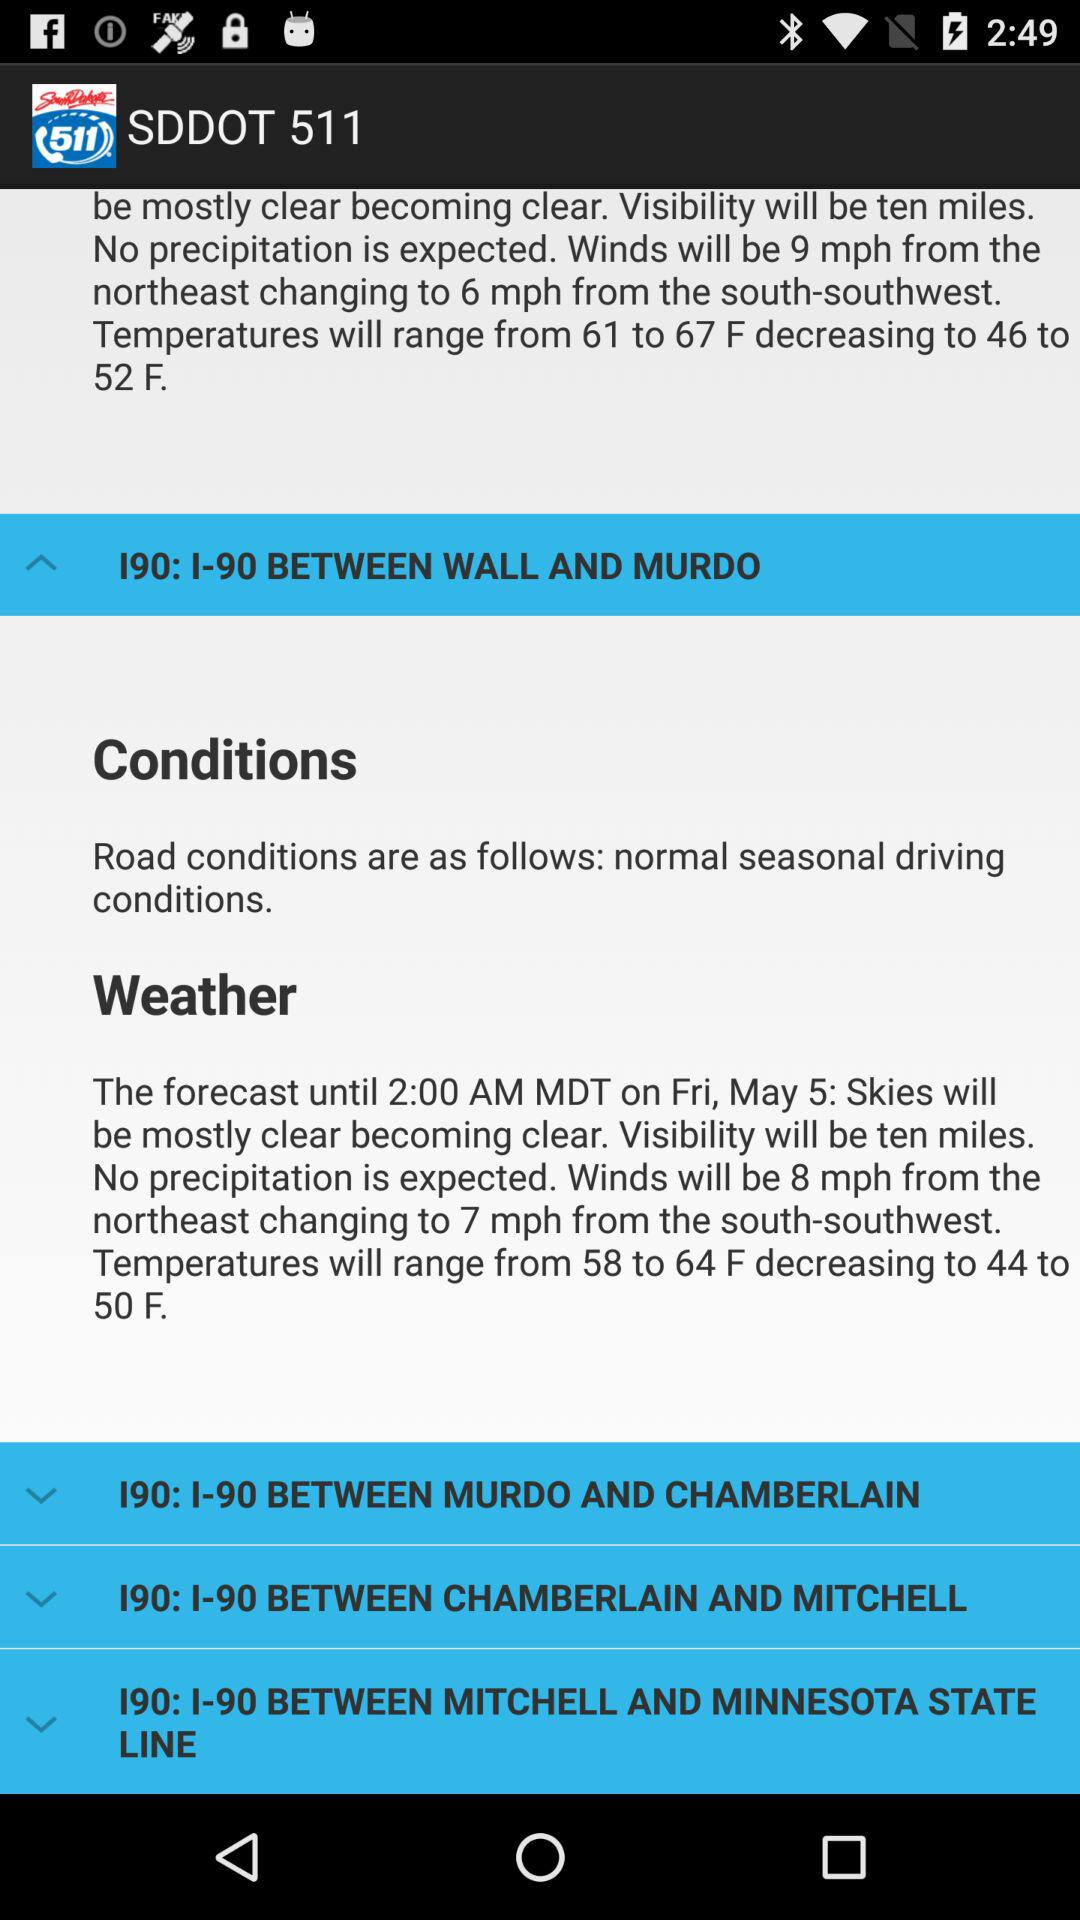What will be the temperature range? The temperature will be range from 61 to 67 F decreasing to 46 to 52 F. 